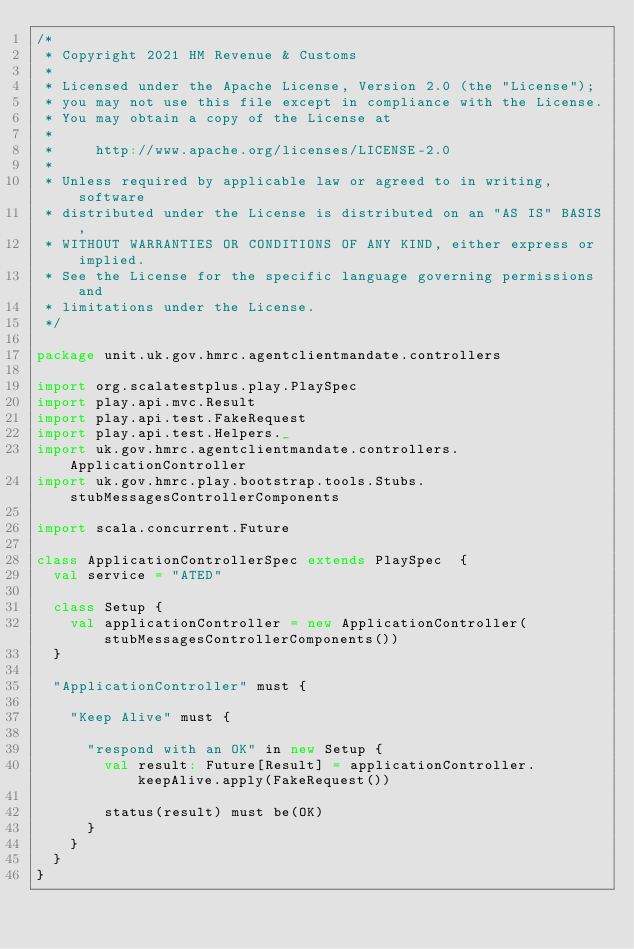<code> <loc_0><loc_0><loc_500><loc_500><_Scala_>/*
 * Copyright 2021 HM Revenue & Customs
 *
 * Licensed under the Apache License, Version 2.0 (the "License");
 * you may not use this file except in compliance with the License.
 * You may obtain a copy of the License at
 *
 *     http://www.apache.org/licenses/LICENSE-2.0
 *
 * Unless required by applicable law or agreed to in writing, software
 * distributed under the License is distributed on an "AS IS" BASIS,
 * WITHOUT WARRANTIES OR CONDITIONS OF ANY KIND, either express or implied.
 * See the License for the specific language governing permissions and
 * limitations under the License.
 */

package unit.uk.gov.hmrc.agentclientmandate.controllers

import org.scalatestplus.play.PlaySpec
import play.api.mvc.Result
import play.api.test.FakeRequest
import play.api.test.Helpers._
import uk.gov.hmrc.agentclientmandate.controllers.ApplicationController
import uk.gov.hmrc.play.bootstrap.tools.Stubs.stubMessagesControllerComponents

import scala.concurrent.Future

class ApplicationControllerSpec extends PlaySpec  {
  val service = "ATED"

  class Setup {
    val applicationController = new ApplicationController(stubMessagesControllerComponents())
  }

  "ApplicationController" must {

    "Keep Alive" must {

      "respond with an OK" in new Setup {
        val result: Future[Result] = applicationController.keepAlive.apply(FakeRequest())

        status(result) must be(OK)
      }
    }
  }
}
</code> 